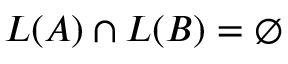<formula> <loc_0><loc_0><loc_500><loc_500>L ( A ) \cap L ( B ) = \emptyset</formula> 